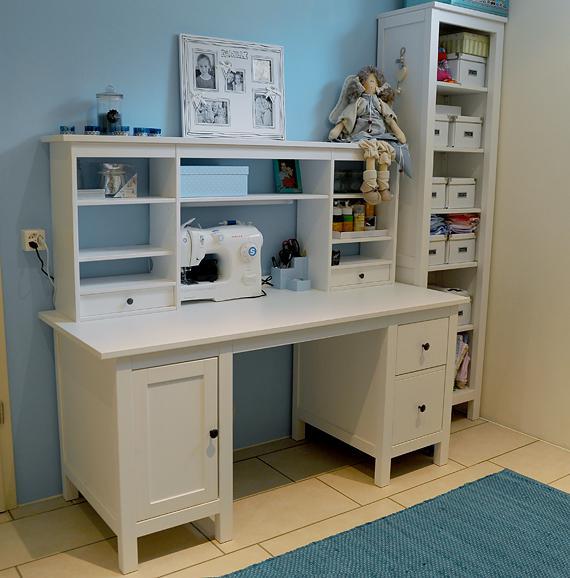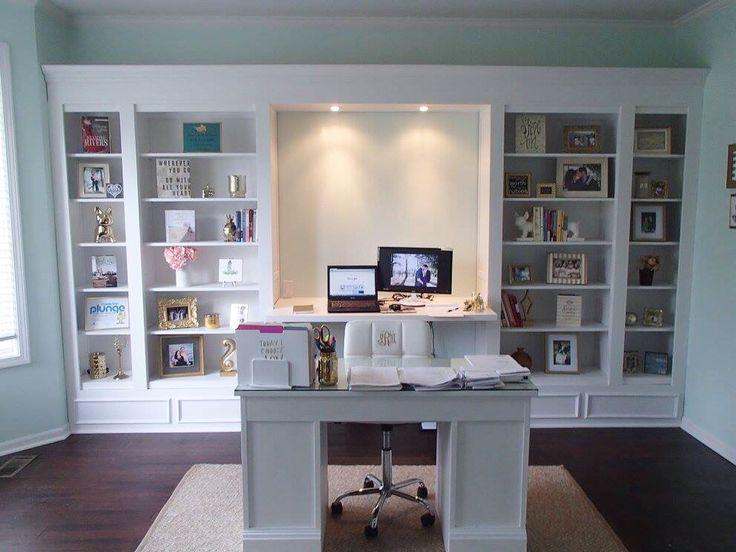The first image is the image on the left, the second image is the image on the right. Evaluate the accuracy of this statement regarding the images: "There is a desk in each image.". Is it true? Answer yes or no. Yes. The first image is the image on the left, the second image is the image on the right. Analyze the images presented: Is the assertion "One image features a traditional desk up against a wall, with a hutch on top of the desk, a one-door cabinet underneath on the left, and two drawers on the right." valid? Answer yes or no. Yes. 